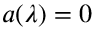Convert formula to latex. <formula><loc_0><loc_0><loc_500><loc_500>a ( \lambda ) = 0</formula> 